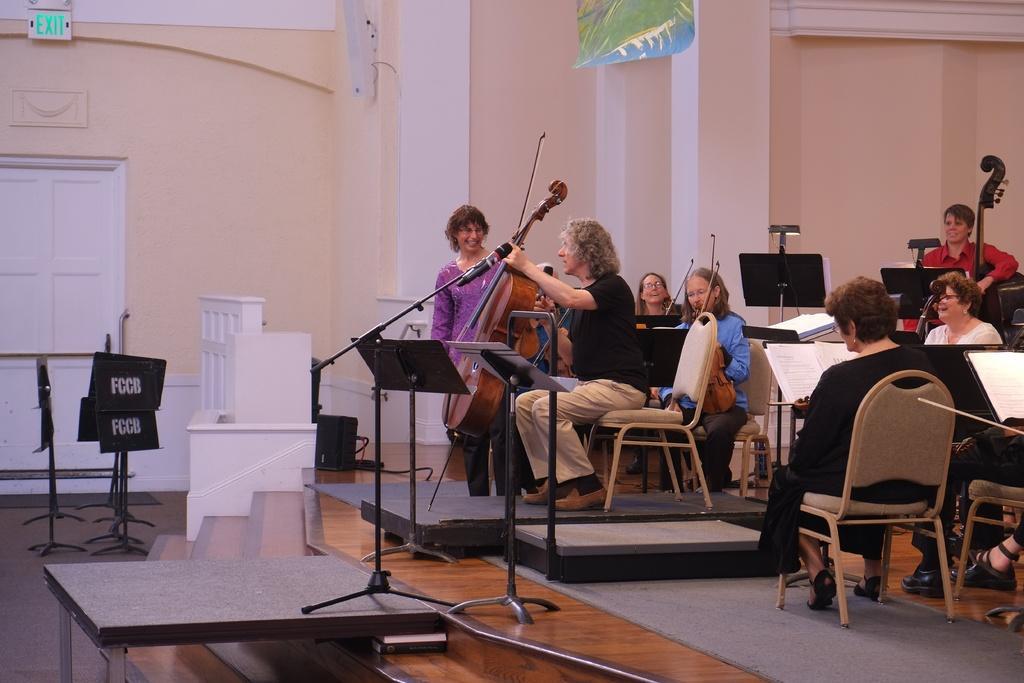In one or two sentences, can you explain what this image depicts? On the background we can see a wall, door and a exit sign board. Here we can see all persons sitting on chairs and playing musical instruments and we can see books. This is a platform. We can see one woman is standing and she is holding a smile on her face. 